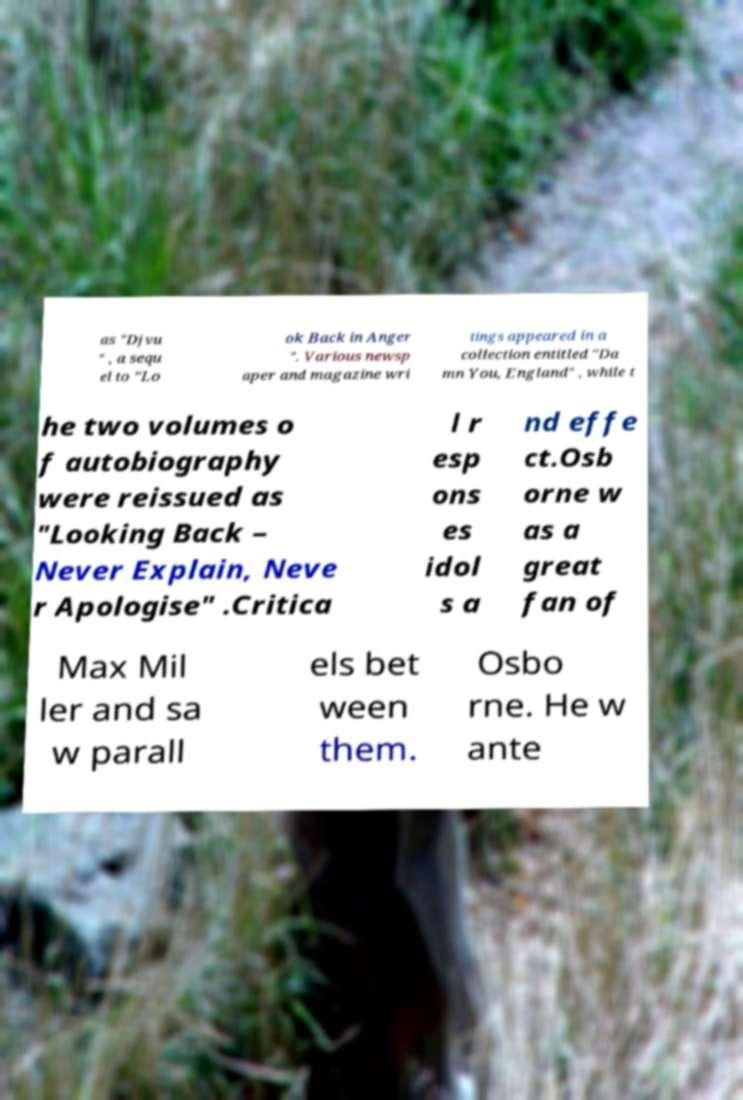What messages or text are displayed in this image? I need them in a readable, typed format. as "Djvu " , a sequ el to "Lo ok Back in Anger ". Various newsp aper and magazine wri tings appeared in a collection entitled "Da mn You, England" , while t he two volumes o f autobiography were reissued as "Looking Back – Never Explain, Neve r Apologise" .Critica l r esp ons es idol s a nd effe ct.Osb orne w as a great fan of Max Mil ler and sa w parall els bet ween them. Osbo rne. He w ante 